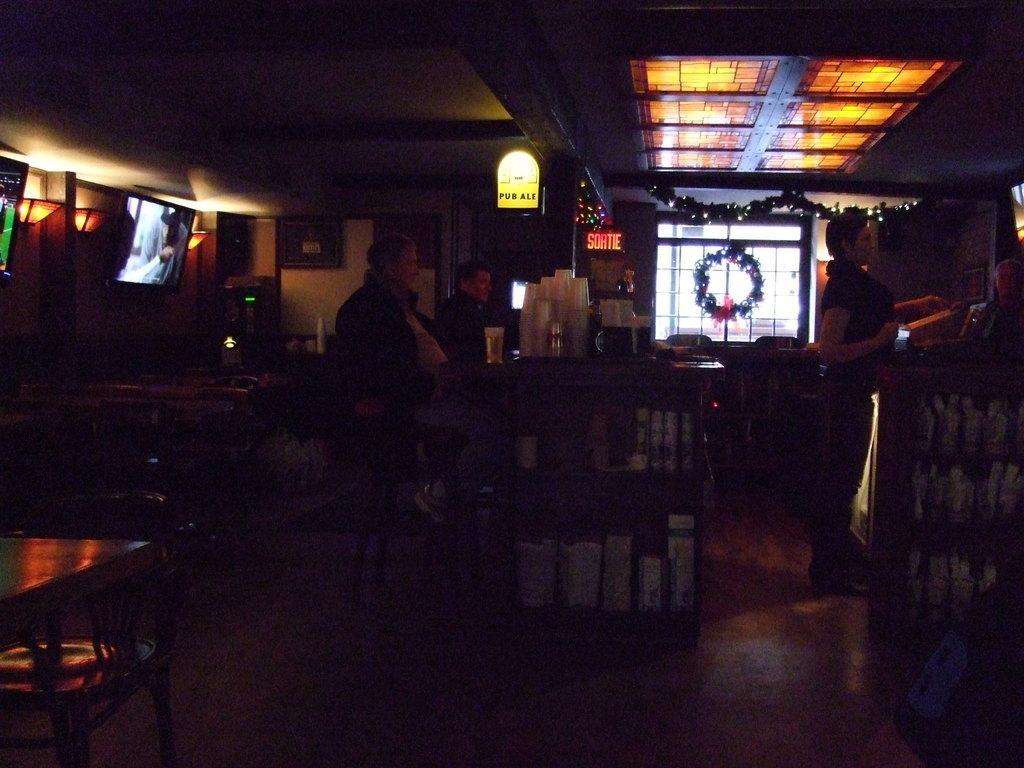In one or two sentences, can you explain what this image depicts? In this picture we can see a person standing on the floor. This is the table. Here we can see two persons sitting on the chairs. And there is a screen. This is the floor and there is a window. And this is the light. 